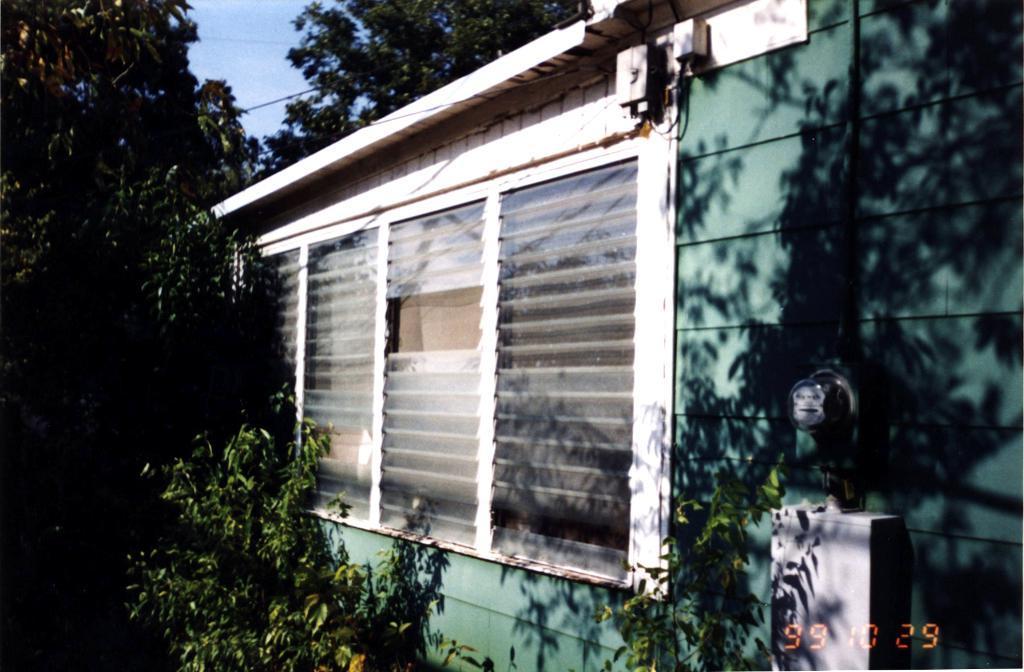Please provide a concise description of this image. In this image I can see building in green color. I can also see glass windows, background I can see trees in green color, sky in blue color. 